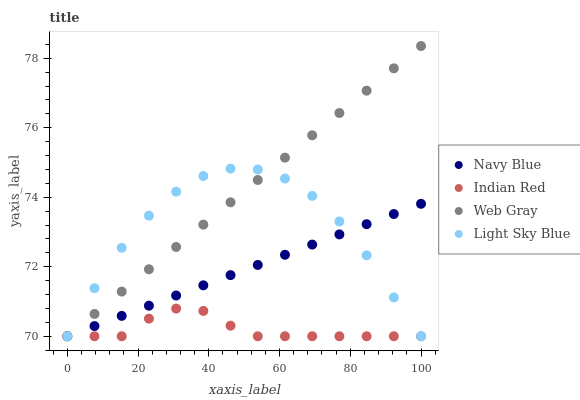Does Indian Red have the minimum area under the curve?
Answer yes or no. Yes. Does Web Gray have the maximum area under the curve?
Answer yes or no. Yes. Does Web Gray have the minimum area under the curve?
Answer yes or no. No. Does Indian Red have the maximum area under the curve?
Answer yes or no. No. Is Navy Blue the smoothest?
Answer yes or no. Yes. Is Light Sky Blue the roughest?
Answer yes or no. Yes. Is Web Gray the smoothest?
Answer yes or no. No. Is Web Gray the roughest?
Answer yes or no. No. Does Navy Blue have the lowest value?
Answer yes or no. Yes. Does Web Gray have the highest value?
Answer yes or no. Yes. Does Indian Red have the highest value?
Answer yes or no. No. Does Indian Red intersect Web Gray?
Answer yes or no. Yes. Is Indian Red less than Web Gray?
Answer yes or no. No. Is Indian Red greater than Web Gray?
Answer yes or no. No. 